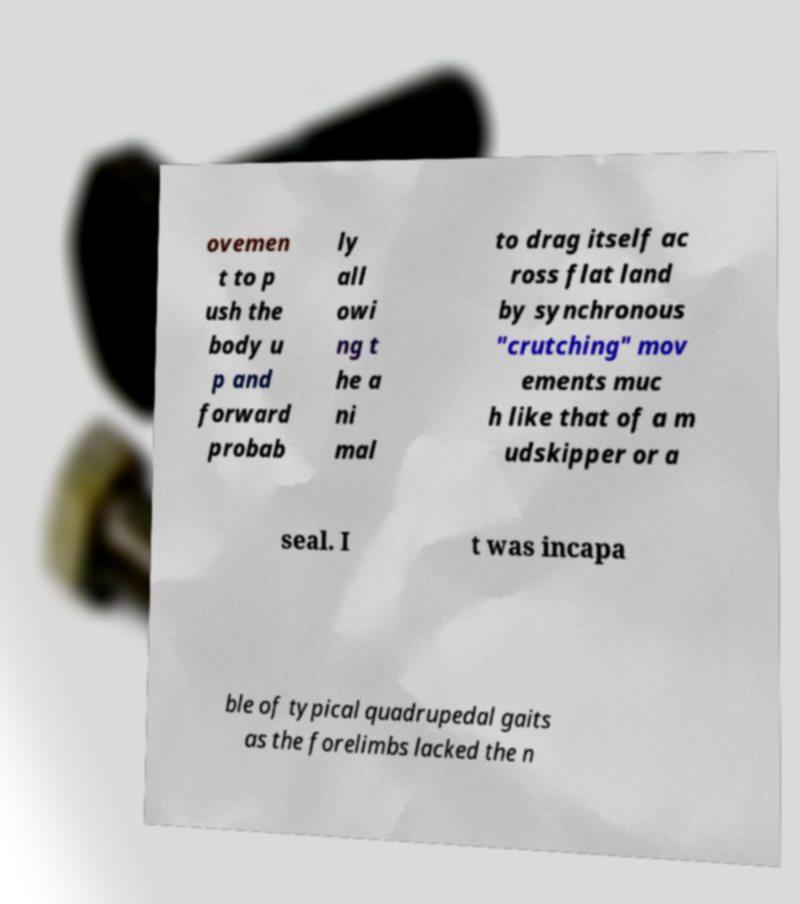I need the written content from this picture converted into text. Can you do that? ovemen t to p ush the body u p and forward probab ly all owi ng t he a ni mal to drag itself ac ross flat land by synchronous "crutching" mov ements muc h like that of a m udskipper or a seal. I t was incapa ble of typical quadrupedal gaits as the forelimbs lacked the n 